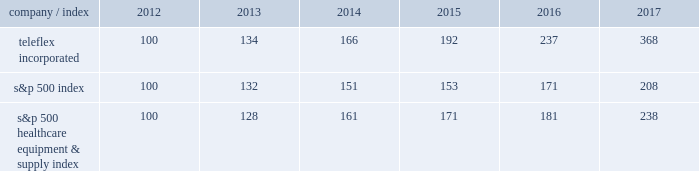Stock performance graph the following graph provides a comparison of five year cumulative total stockholder returns of teleflex common stock , the standard a0& poor 2019s ( s&p ) 500 stock index and the s&p 500 healthcare equipment & supply index .
The annual changes for the five-year period shown on the graph are based on the assumption that $ 100 had been invested in teleflex common stock and each index on december a031 , 2012 and that all dividends were reinvested .
Market performance .
S&p 500 healthcare equipment & supply index 100 128 161 171 181 238 .
What is roi of an investment in teleflex incorporated in 2012 and sold in 2017? 
Computations: ((368 - 100) / 100)
Answer: 2.68. Stock performance graph the following graph provides a comparison of five year cumulative total stockholder returns of teleflex common stock , the standard a0& poor 2019s ( s&p ) 500 stock index and the s&p 500 healthcare equipment & supply index .
The annual changes for the five-year period shown on the graph are based on the assumption that $ 100 had been invested in teleflex common stock and each index on december a031 , 2012 and that all dividends were reinvested .
Market performance .
S&p 500 healthcare equipment & supply index 100 128 161 171 181 238 .
What is roi of an investment in s&p 500 index in 2012 and sold in 2017? 
Computations: ((208 - 100) / 100)
Answer: 1.08. 